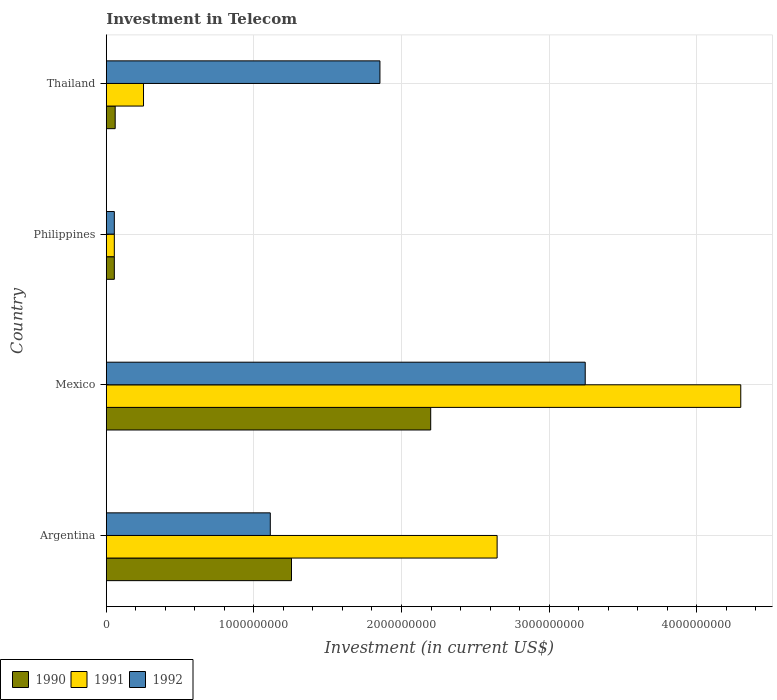Are the number of bars per tick equal to the number of legend labels?
Keep it short and to the point. Yes. How many bars are there on the 4th tick from the bottom?
Give a very brief answer. 3. What is the label of the 1st group of bars from the top?
Offer a very short reply. Thailand. In how many cases, is the number of bars for a given country not equal to the number of legend labels?
Your answer should be very brief. 0. What is the amount invested in telecom in 1992 in Thailand?
Your answer should be very brief. 1.85e+09. Across all countries, what is the maximum amount invested in telecom in 1992?
Your response must be concise. 3.24e+09. Across all countries, what is the minimum amount invested in telecom in 1991?
Ensure brevity in your answer.  5.42e+07. In which country was the amount invested in telecom in 1991 maximum?
Provide a short and direct response. Mexico. In which country was the amount invested in telecom in 1990 minimum?
Provide a short and direct response. Philippines. What is the total amount invested in telecom in 1992 in the graph?
Your answer should be very brief. 6.26e+09. What is the difference between the amount invested in telecom in 1990 in Mexico and that in Thailand?
Your answer should be compact. 2.14e+09. What is the difference between the amount invested in telecom in 1992 in Argentina and the amount invested in telecom in 1991 in Mexico?
Your response must be concise. -3.19e+09. What is the average amount invested in telecom in 1990 per country?
Your answer should be very brief. 8.92e+08. What is the difference between the amount invested in telecom in 1990 and amount invested in telecom in 1992 in Thailand?
Your response must be concise. -1.79e+09. In how many countries, is the amount invested in telecom in 1990 greater than 1400000000 US$?
Your response must be concise. 1. What is the ratio of the amount invested in telecom in 1991 in Argentina to that in Thailand?
Provide a succinct answer. 10.51. Is the amount invested in telecom in 1991 in Philippines less than that in Thailand?
Make the answer very short. Yes. What is the difference between the highest and the second highest amount invested in telecom in 1990?
Make the answer very short. 9.43e+08. What is the difference between the highest and the lowest amount invested in telecom in 1990?
Give a very brief answer. 2.14e+09. In how many countries, is the amount invested in telecom in 1991 greater than the average amount invested in telecom in 1991 taken over all countries?
Ensure brevity in your answer.  2. Is it the case that in every country, the sum of the amount invested in telecom in 1990 and amount invested in telecom in 1992 is greater than the amount invested in telecom in 1991?
Ensure brevity in your answer.  No. Are all the bars in the graph horizontal?
Offer a very short reply. Yes. How many countries are there in the graph?
Your answer should be very brief. 4. What is the difference between two consecutive major ticks on the X-axis?
Offer a very short reply. 1.00e+09. Are the values on the major ticks of X-axis written in scientific E-notation?
Make the answer very short. No. Does the graph contain any zero values?
Your answer should be compact. No. Where does the legend appear in the graph?
Keep it short and to the point. Bottom left. How many legend labels are there?
Ensure brevity in your answer.  3. How are the legend labels stacked?
Your answer should be compact. Horizontal. What is the title of the graph?
Offer a very short reply. Investment in Telecom. Does "1960" appear as one of the legend labels in the graph?
Provide a short and direct response. No. What is the label or title of the X-axis?
Your response must be concise. Investment (in current US$). What is the label or title of the Y-axis?
Give a very brief answer. Country. What is the Investment (in current US$) of 1990 in Argentina?
Your response must be concise. 1.25e+09. What is the Investment (in current US$) in 1991 in Argentina?
Your answer should be very brief. 2.65e+09. What is the Investment (in current US$) in 1992 in Argentina?
Provide a short and direct response. 1.11e+09. What is the Investment (in current US$) in 1990 in Mexico?
Make the answer very short. 2.20e+09. What is the Investment (in current US$) in 1991 in Mexico?
Your response must be concise. 4.30e+09. What is the Investment (in current US$) in 1992 in Mexico?
Offer a very short reply. 3.24e+09. What is the Investment (in current US$) in 1990 in Philippines?
Provide a short and direct response. 5.42e+07. What is the Investment (in current US$) of 1991 in Philippines?
Provide a short and direct response. 5.42e+07. What is the Investment (in current US$) in 1992 in Philippines?
Offer a terse response. 5.42e+07. What is the Investment (in current US$) of 1990 in Thailand?
Offer a terse response. 6.00e+07. What is the Investment (in current US$) of 1991 in Thailand?
Make the answer very short. 2.52e+08. What is the Investment (in current US$) of 1992 in Thailand?
Offer a terse response. 1.85e+09. Across all countries, what is the maximum Investment (in current US$) of 1990?
Provide a short and direct response. 2.20e+09. Across all countries, what is the maximum Investment (in current US$) of 1991?
Ensure brevity in your answer.  4.30e+09. Across all countries, what is the maximum Investment (in current US$) of 1992?
Your answer should be very brief. 3.24e+09. Across all countries, what is the minimum Investment (in current US$) in 1990?
Keep it short and to the point. 5.42e+07. Across all countries, what is the minimum Investment (in current US$) of 1991?
Keep it short and to the point. 5.42e+07. Across all countries, what is the minimum Investment (in current US$) of 1992?
Provide a short and direct response. 5.42e+07. What is the total Investment (in current US$) in 1990 in the graph?
Your answer should be compact. 3.57e+09. What is the total Investment (in current US$) of 1991 in the graph?
Keep it short and to the point. 7.25e+09. What is the total Investment (in current US$) of 1992 in the graph?
Give a very brief answer. 6.26e+09. What is the difference between the Investment (in current US$) in 1990 in Argentina and that in Mexico?
Offer a terse response. -9.43e+08. What is the difference between the Investment (in current US$) in 1991 in Argentina and that in Mexico?
Keep it short and to the point. -1.65e+09. What is the difference between the Investment (in current US$) in 1992 in Argentina and that in Mexico?
Provide a short and direct response. -2.13e+09. What is the difference between the Investment (in current US$) in 1990 in Argentina and that in Philippines?
Your response must be concise. 1.20e+09. What is the difference between the Investment (in current US$) in 1991 in Argentina and that in Philippines?
Provide a short and direct response. 2.59e+09. What is the difference between the Investment (in current US$) in 1992 in Argentina and that in Philippines?
Ensure brevity in your answer.  1.06e+09. What is the difference between the Investment (in current US$) in 1990 in Argentina and that in Thailand?
Make the answer very short. 1.19e+09. What is the difference between the Investment (in current US$) in 1991 in Argentina and that in Thailand?
Make the answer very short. 2.40e+09. What is the difference between the Investment (in current US$) in 1992 in Argentina and that in Thailand?
Offer a very short reply. -7.43e+08. What is the difference between the Investment (in current US$) of 1990 in Mexico and that in Philippines?
Your answer should be compact. 2.14e+09. What is the difference between the Investment (in current US$) of 1991 in Mexico and that in Philippines?
Your answer should be very brief. 4.24e+09. What is the difference between the Investment (in current US$) of 1992 in Mexico and that in Philippines?
Your answer should be very brief. 3.19e+09. What is the difference between the Investment (in current US$) in 1990 in Mexico and that in Thailand?
Keep it short and to the point. 2.14e+09. What is the difference between the Investment (in current US$) of 1991 in Mexico and that in Thailand?
Keep it short and to the point. 4.05e+09. What is the difference between the Investment (in current US$) of 1992 in Mexico and that in Thailand?
Offer a terse response. 1.39e+09. What is the difference between the Investment (in current US$) of 1990 in Philippines and that in Thailand?
Give a very brief answer. -5.80e+06. What is the difference between the Investment (in current US$) of 1991 in Philippines and that in Thailand?
Ensure brevity in your answer.  -1.98e+08. What is the difference between the Investment (in current US$) of 1992 in Philippines and that in Thailand?
Ensure brevity in your answer.  -1.80e+09. What is the difference between the Investment (in current US$) in 1990 in Argentina and the Investment (in current US$) in 1991 in Mexico?
Give a very brief answer. -3.04e+09. What is the difference between the Investment (in current US$) of 1990 in Argentina and the Investment (in current US$) of 1992 in Mexico?
Your answer should be compact. -1.99e+09. What is the difference between the Investment (in current US$) in 1991 in Argentina and the Investment (in current US$) in 1992 in Mexico?
Make the answer very short. -5.97e+08. What is the difference between the Investment (in current US$) in 1990 in Argentina and the Investment (in current US$) in 1991 in Philippines?
Provide a short and direct response. 1.20e+09. What is the difference between the Investment (in current US$) of 1990 in Argentina and the Investment (in current US$) of 1992 in Philippines?
Provide a succinct answer. 1.20e+09. What is the difference between the Investment (in current US$) of 1991 in Argentina and the Investment (in current US$) of 1992 in Philippines?
Offer a terse response. 2.59e+09. What is the difference between the Investment (in current US$) in 1990 in Argentina and the Investment (in current US$) in 1991 in Thailand?
Offer a terse response. 1.00e+09. What is the difference between the Investment (in current US$) in 1990 in Argentina and the Investment (in current US$) in 1992 in Thailand?
Make the answer very short. -5.99e+08. What is the difference between the Investment (in current US$) in 1991 in Argentina and the Investment (in current US$) in 1992 in Thailand?
Offer a terse response. 7.94e+08. What is the difference between the Investment (in current US$) in 1990 in Mexico and the Investment (in current US$) in 1991 in Philippines?
Keep it short and to the point. 2.14e+09. What is the difference between the Investment (in current US$) of 1990 in Mexico and the Investment (in current US$) of 1992 in Philippines?
Your answer should be very brief. 2.14e+09. What is the difference between the Investment (in current US$) of 1991 in Mexico and the Investment (in current US$) of 1992 in Philippines?
Keep it short and to the point. 4.24e+09. What is the difference between the Investment (in current US$) of 1990 in Mexico and the Investment (in current US$) of 1991 in Thailand?
Provide a short and direct response. 1.95e+09. What is the difference between the Investment (in current US$) of 1990 in Mexico and the Investment (in current US$) of 1992 in Thailand?
Provide a succinct answer. 3.44e+08. What is the difference between the Investment (in current US$) of 1991 in Mexico and the Investment (in current US$) of 1992 in Thailand?
Keep it short and to the point. 2.44e+09. What is the difference between the Investment (in current US$) in 1990 in Philippines and the Investment (in current US$) in 1991 in Thailand?
Ensure brevity in your answer.  -1.98e+08. What is the difference between the Investment (in current US$) of 1990 in Philippines and the Investment (in current US$) of 1992 in Thailand?
Make the answer very short. -1.80e+09. What is the difference between the Investment (in current US$) in 1991 in Philippines and the Investment (in current US$) in 1992 in Thailand?
Your answer should be compact. -1.80e+09. What is the average Investment (in current US$) of 1990 per country?
Your answer should be compact. 8.92e+08. What is the average Investment (in current US$) of 1991 per country?
Offer a very short reply. 1.81e+09. What is the average Investment (in current US$) of 1992 per country?
Make the answer very short. 1.57e+09. What is the difference between the Investment (in current US$) of 1990 and Investment (in current US$) of 1991 in Argentina?
Offer a very short reply. -1.39e+09. What is the difference between the Investment (in current US$) of 1990 and Investment (in current US$) of 1992 in Argentina?
Ensure brevity in your answer.  1.44e+08. What is the difference between the Investment (in current US$) of 1991 and Investment (in current US$) of 1992 in Argentina?
Provide a short and direct response. 1.54e+09. What is the difference between the Investment (in current US$) in 1990 and Investment (in current US$) in 1991 in Mexico?
Your response must be concise. -2.10e+09. What is the difference between the Investment (in current US$) of 1990 and Investment (in current US$) of 1992 in Mexico?
Provide a succinct answer. -1.05e+09. What is the difference between the Investment (in current US$) in 1991 and Investment (in current US$) in 1992 in Mexico?
Your answer should be very brief. 1.05e+09. What is the difference between the Investment (in current US$) in 1990 and Investment (in current US$) in 1991 in Philippines?
Provide a short and direct response. 0. What is the difference between the Investment (in current US$) of 1990 and Investment (in current US$) of 1992 in Philippines?
Provide a succinct answer. 0. What is the difference between the Investment (in current US$) of 1990 and Investment (in current US$) of 1991 in Thailand?
Ensure brevity in your answer.  -1.92e+08. What is the difference between the Investment (in current US$) of 1990 and Investment (in current US$) of 1992 in Thailand?
Provide a succinct answer. -1.79e+09. What is the difference between the Investment (in current US$) in 1991 and Investment (in current US$) in 1992 in Thailand?
Offer a very short reply. -1.60e+09. What is the ratio of the Investment (in current US$) of 1990 in Argentina to that in Mexico?
Make the answer very short. 0.57. What is the ratio of the Investment (in current US$) in 1991 in Argentina to that in Mexico?
Offer a terse response. 0.62. What is the ratio of the Investment (in current US$) in 1992 in Argentina to that in Mexico?
Offer a very short reply. 0.34. What is the ratio of the Investment (in current US$) of 1990 in Argentina to that in Philippines?
Your answer should be very brief. 23.15. What is the ratio of the Investment (in current US$) in 1991 in Argentina to that in Philippines?
Your answer should be compact. 48.86. What is the ratio of the Investment (in current US$) of 1992 in Argentina to that in Philippines?
Your response must be concise. 20.5. What is the ratio of the Investment (in current US$) of 1990 in Argentina to that in Thailand?
Ensure brevity in your answer.  20.91. What is the ratio of the Investment (in current US$) of 1991 in Argentina to that in Thailand?
Your answer should be compact. 10.51. What is the ratio of the Investment (in current US$) of 1992 in Argentina to that in Thailand?
Give a very brief answer. 0.6. What is the ratio of the Investment (in current US$) of 1990 in Mexico to that in Philippines?
Provide a succinct answer. 40.55. What is the ratio of the Investment (in current US$) of 1991 in Mexico to that in Philippines?
Your response must be concise. 79.32. What is the ratio of the Investment (in current US$) in 1992 in Mexico to that in Philippines?
Provide a short and direct response. 59.87. What is the ratio of the Investment (in current US$) in 1990 in Mexico to that in Thailand?
Your answer should be very brief. 36.63. What is the ratio of the Investment (in current US$) of 1991 in Mexico to that in Thailand?
Offer a very short reply. 17.06. What is the ratio of the Investment (in current US$) of 1992 in Mexico to that in Thailand?
Make the answer very short. 1.75. What is the ratio of the Investment (in current US$) of 1990 in Philippines to that in Thailand?
Provide a short and direct response. 0.9. What is the ratio of the Investment (in current US$) in 1991 in Philippines to that in Thailand?
Provide a succinct answer. 0.22. What is the ratio of the Investment (in current US$) in 1992 in Philippines to that in Thailand?
Make the answer very short. 0.03. What is the difference between the highest and the second highest Investment (in current US$) in 1990?
Make the answer very short. 9.43e+08. What is the difference between the highest and the second highest Investment (in current US$) in 1991?
Ensure brevity in your answer.  1.65e+09. What is the difference between the highest and the second highest Investment (in current US$) in 1992?
Your answer should be compact. 1.39e+09. What is the difference between the highest and the lowest Investment (in current US$) of 1990?
Give a very brief answer. 2.14e+09. What is the difference between the highest and the lowest Investment (in current US$) of 1991?
Keep it short and to the point. 4.24e+09. What is the difference between the highest and the lowest Investment (in current US$) of 1992?
Make the answer very short. 3.19e+09. 